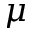<formula> <loc_0><loc_0><loc_500><loc_500>\mu</formula> 